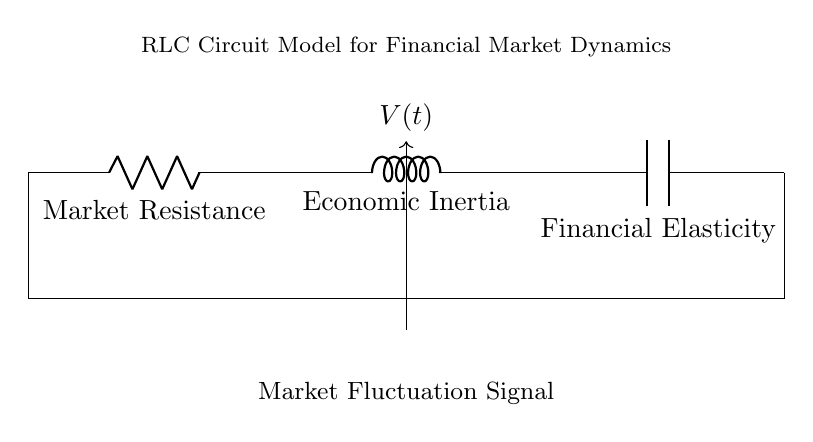What type of circuit is displayed? The circuit is an RLC circuit, which includes a resistor, inductor, and capacitor connected in series. The combination of these components forms a circuit that can model various dynamic behaviors, including market fluctuations.
Answer: RLC What does the symbol R represent? The symbol R in the circuit represents resistance, which relates to the market resistance, a component depicting how the market reacts to price changes and external factors.
Answer: Market Resistance What does the symbol L signify? The symbol L signifies inductance, representing economic inertia that describes the tendency of the market to resist changes in momentum or trends.
Answer: Economic Inertia What does the symbol C denote? The symbol C denotes capacitance, which reflects financial elasticity, indicating how the market can respond to fluctuations in availability of capital or credit.
Answer: Financial Elasticity How many total components are in the circuit? The circuit contains three components: one resistor, one inductor, and one capacitor, indicating the interactions between resistance, inertia, and elasticity in financial markets.
Answer: Three What is the primary function of this RLC circuit in the context of financial modeling? The primary function of the RLC circuit in financial modeling is to represent and analyze the dynamic behavior of financial markets, capturing interactions among resistance, inertia, and elasticity, leading to understanding fluctuations and trends.
Answer: Modeling financial fluctuations In what way does the circuit diagram represent market fluctuations? The circuit diagram represents market fluctuations through the flow of voltage, depicting how market dynamics, influenced by resistance, inertia, and elasticity, can lead to oscillations and varying patterns in market behavior over time.
Answer: Oscillations in market behavior 